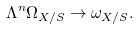<formula> <loc_0><loc_0><loc_500><loc_500>\Lambda ^ { n } \Omega _ { X / S } \to \omega _ { X / S } .</formula> 